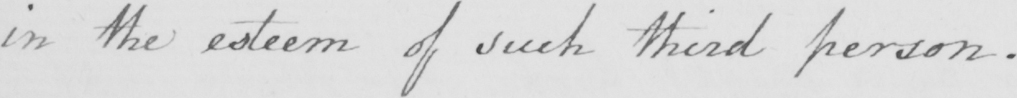What is written in this line of handwriting? in the esteem of such third person . 